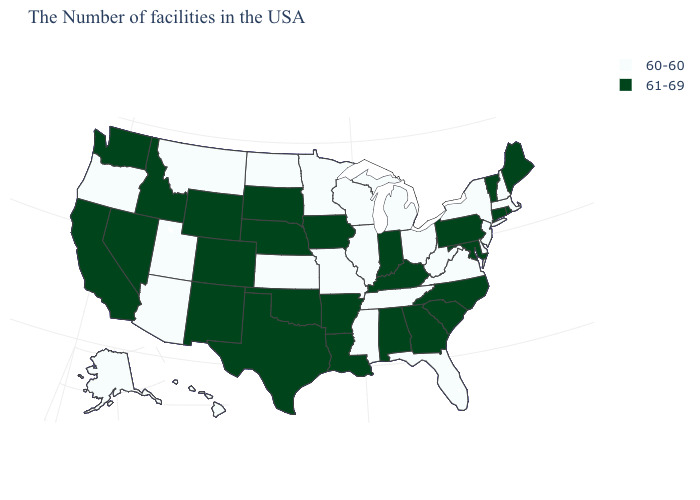What is the value of Connecticut?
Keep it brief. 61-69. What is the value of Tennessee?
Concise answer only. 60-60. Does New Hampshire have the lowest value in the USA?
Quick response, please. Yes. Does South Carolina have a higher value than California?
Short answer required. No. What is the value of Oklahoma?
Answer briefly. 61-69. Does Maryland have a lower value than Massachusetts?
Answer briefly. No. Does Nevada have the highest value in the USA?
Give a very brief answer. Yes. Is the legend a continuous bar?
Write a very short answer. No. What is the highest value in the MidWest ?
Keep it brief. 61-69. Name the states that have a value in the range 60-60?
Quick response, please. Massachusetts, New Hampshire, New York, New Jersey, Delaware, Virginia, West Virginia, Ohio, Florida, Michigan, Tennessee, Wisconsin, Illinois, Mississippi, Missouri, Minnesota, Kansas, North Dakota, Utah, Montana, Arizona, Oregon, Alaska, Hawaii. Does the map have missing data?
Give a very brief answer. No. Name the states that have a value in the range 60-60?
Concise answer only. Massachusetts, New Hampshire, New York, New Jersey, Delaware, Virginia, West Virginia, Ohio, Florida, Michigan, Tennessee, Wisconsin, Illinois, Mississippi, Missouri, Minnesota, Kansas, North Dakota, Utah, Montana, Arizona, Oregon, Alaska, Hawaii. What is the value of New Jersey?
Give a very brief answer. 60-60. Among the states that border Nevada , which have the lowest value?
Give a very brief answer. Utah, Arizona, Oregon. Among the states that border Kansas , which have the lowest value?
Short answer required. Missouri. 